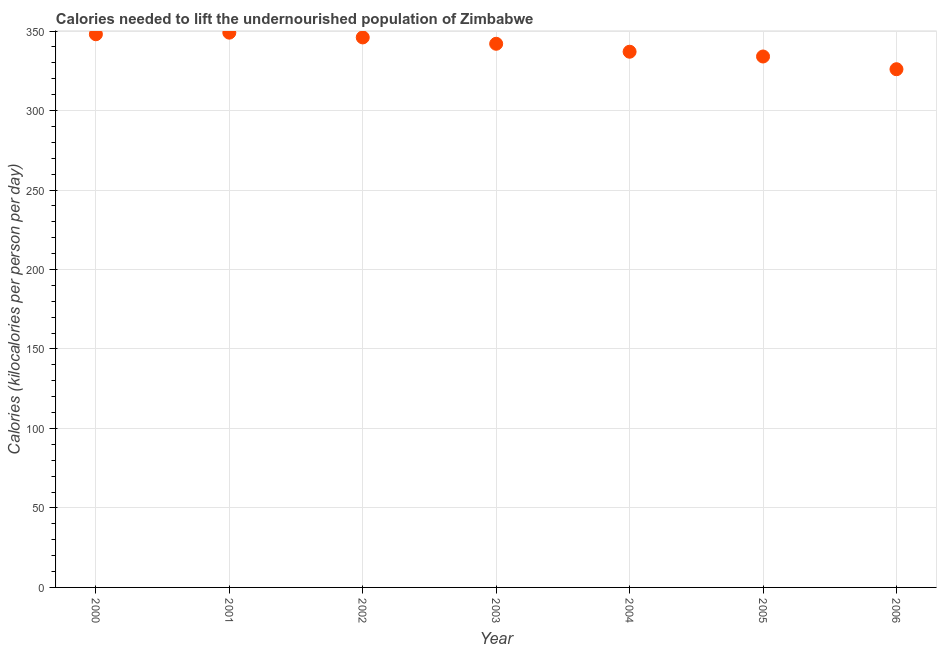What is the depth of food deficit in 2004?
Ensure brevity in your answer.  337. Across all years, what is the maximum depth of food deficit?
Ensure brevity in your answer.  349. Across all years, what is the minimum depth of food deficit?
Your response must be concise. 326. In which year was the depth of food deficit maximum?
Offer a very short reply. 2001. In which year was the depth of food deficit minimum?
Give a very brief answer. 2006. What is the sum of the depth of food deficit?
Make the answer very short. 2382. What is the difference between the depth of food deficit in 2001 and 2002?
Your answer should be compact. 3. What is the average depth of food deficit per year?
Your answer should be very brief. 340.29. What is the median depth of food deficit?
Make the answer very short. 342. In how many years, is the depth of food deficit greater than 50 kilocalories?
Ensure brevity in your answer.  7. Do a majority of the years between 2006 and 2002 (inclusive) have depth of food deficit greater than 80 kilocalories?
Offer a terse response. Yes. What is the ratio of the depth of food deficit in 2001 to that in 2005?
Your answer should be compact. 1.04. Is the depth of food deficit in 2002 less than that in 2005?
Offer a very short reply. No. Is the difference between the depth of food deficit in 2000 and 2001 greater than the difference between any two years?
Your answer should be compact. No. Is the sum of the depth of food deficit in 2003 and 2004 greater than the maximum depth of food deficit across all years?
Your answer should be compact. Yes. What is the difference between the highest and the lowest depth of food deficit?
Your answer should be very brief. 23. In how many years, is the depth of food deficit greater than the average depth of food deficit taken over all years?
Your response must be concise. 4. Does the depth of food deficit monotonically increase over the years?
Keep it short and to the point. No. How many dotlines are there?
Make the answer very short. 1. What is the difference between two consecutive major ticks on the Y-axis?
Your answer should be very brief. 50. Are the values on the major ticks of Y-axis written in scientific E-notation?
Keep it short and to the point. No. Does the graph contain any zero values?
Give a very brief answer. No. Does the graph contain grids?
Ensure brevity in your answer.  Yes. What is the title of the graph?
Give a very brief answer. Calories needed to lift the undernourished population of Zimbabwe. What is the label or title of the Y-axis?
Your answer should be very brief. Calories (kilocalories per person per day). What is the Calories (kilocalories per person per day) in 2000?
Keep it short and to the point. 348. What is the Calories (kilocalories per person per day) in 2001?
Give a very brief answer. 349. What is the Calories (kilocalories per person per day) in 2002?
Provide a short and direct response. 346. What is the Calories (kilocalories per person per day) in 2003?
Make the answer very short. 342. What is the Calories (kilocalories per person per day) in 2004?
Offer a terse response. 337. What is the Calories (kilocalories per person per day) in 2005?
Your response must be concise. 334. What is the Calories (kilocalories per person per day) in 2006?
Ensure brevity in your answer.  326. What is the difference between the Calories (kilocalories per person per day) in 2000 and 2003?
Ensure brevity in your answer.  6. What is the difference between the Calories (kilocalories per person per day) in 2000 and 2006?
Keep it short and to the point. 22. What is the difference between the Calories (kilocalories per person per day) in 2001 and 2003?
Your response must be concise. 7. What is the difference between the Calories (kilocalories per person per day) in 2001 and 2005?
Your answer should be very brief. 15. What is the difference between the Calories (kilocalories per person per day) in 2001 and 2006?
Provide a short and direct response. 23. What is the difference between the Calories (kilocalories per person per day) in 2002 and 2003?
Give a very brief answer. 4. What is the difference between the Calories (kilocalories per person per day) in 2003 and 2005?
Provide a short and direct response. 8. What is the ratio of the Calories (kilocalories per person per day) in 2000 to that in 2002?
Give a very brief answer. 1.01. What is the ratio of the Calories (kilocalories per person per day) in 2000 to that in 2004?
Your response must be concise. 1.03. What is the ratio of the Calories (kilocalories per person per day) in 2000 to that in 2005?
Offer a very short reply. 1.04. What is the ratio of the Calories (kilocalories per person per day) in 2000 to that in 2006?
Keep it short and to the point. 1.07. What is the ratio of the Calories (kilocalories per person per day) in 2001 to that in 2003?
Make the answer very short. 1.02. What is the ratio of the Calories (kilocalories per person per day) in 2001 to that in 2004?
Your answer should be very brief. 1.04. What is the ratio of the Calories (kilocalories per person per day) in 2001 to that in 2005?
Your answer should be very brief. 1.04. What is the ratio of the Calories (kilocalories per person per day) in 2001 to that in 2006?
Keep it short and to the point. 1.07. What is the ratio of the Calories (kilocalories per person per day) in 2002 to that in 2005?
Your answer should be compact. 1.04. What is the ratio of the Calories (kilocalories per person per day) in 2002 to that in 2006?
Your answer should be compact. 1.06. What is the ratio of the Calories (kilocalories per person per day) in 2003 to that in 2004?
Your response must be concise. 1.01. What is the ratio of the Calories (kilocalories per person per day) in 2003 to that in 2005?
Your answer should be very brief. 1.02. What is the ratio of the Calories (kilocalories per person per day) in 2003 to that in 2006?
Give a very brief answer. 1.05. What is the ratio of the Calories (kilocalories per person per day) in 2004 to that in 2006?
Offer a terse response. 1.03. 